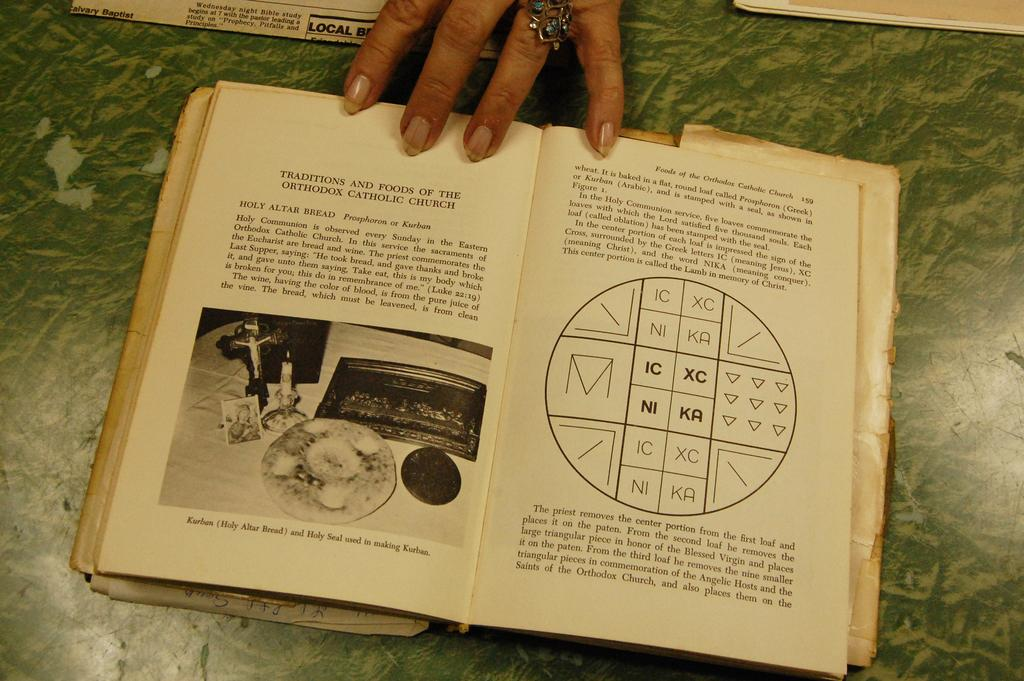<image>
Summarize the visual content of the image. A opened book of food from a Catholic Church book. 